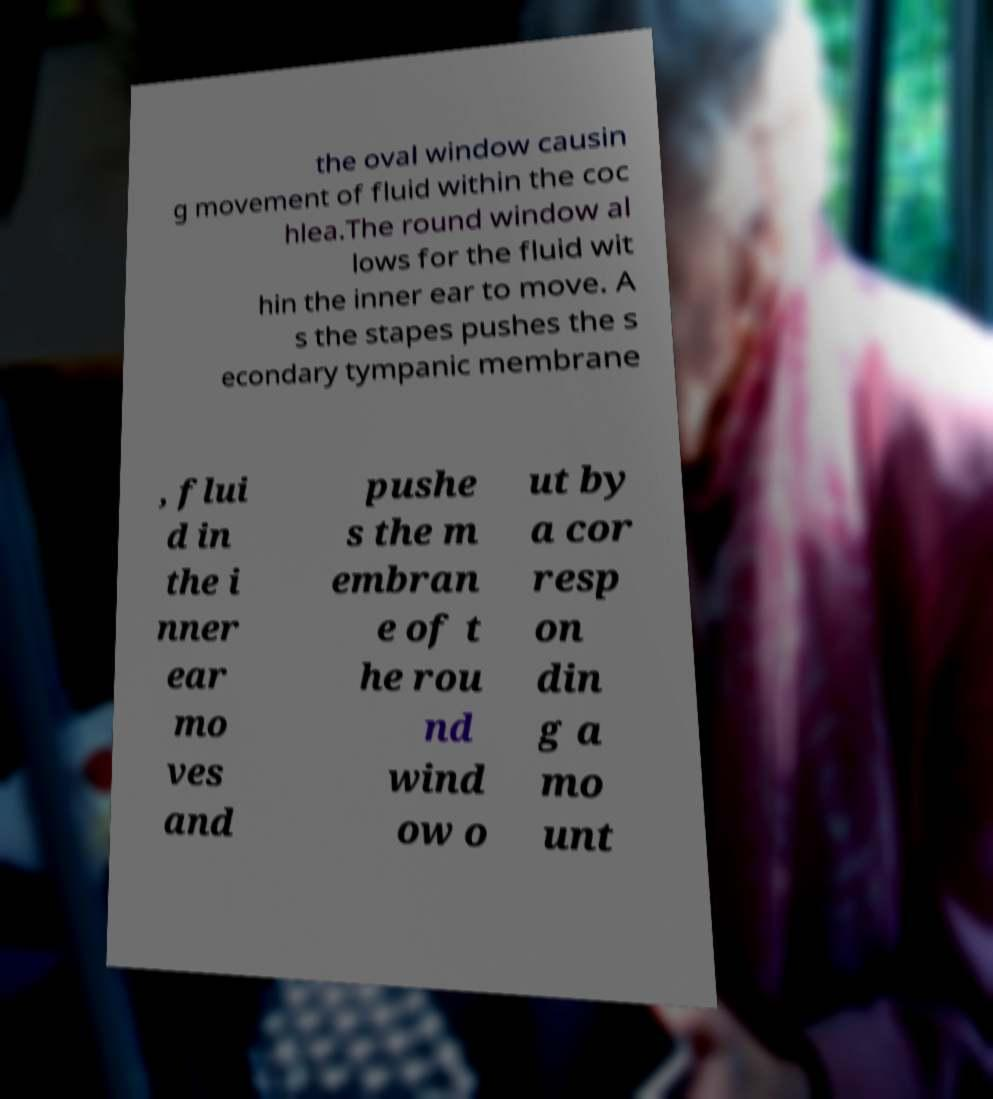Could you assist in decoding the text presented in this image and type it out clearly? the oval window causin g movement of fluid within the coc hlea.The round window al lows for the fluid wit hin the inner ear to move. A s the stapes pushes the s econdary tympanic membrane , flui d in the i nner ear mo ves and pushe s the m embran e of t he rou nd wind ow o ut by a cor resp on din g a mo unt 